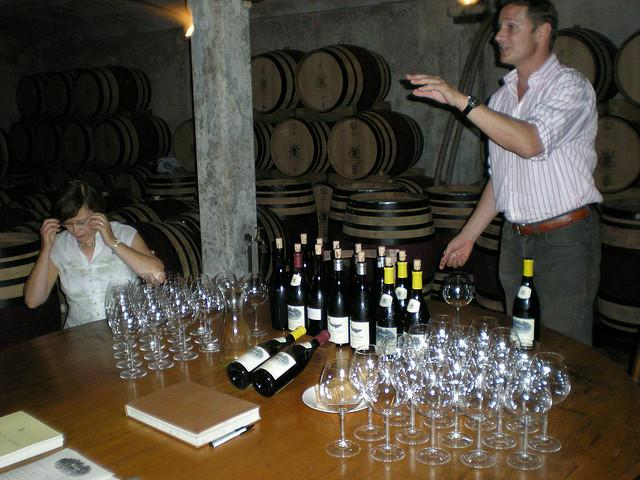What kind of wood is used to make the barrels in the background? Please explain your reasoning. oak. The establishment has wine glasses showing that they serve alcohol.  barrells holding alcohol are always made of this wood because the flavor is agreeable to whiskey and beer. 